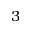Convert formula to latex. <formula><loc_0><loc_0><loc_500><loc_500>3</formula> 